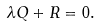<formula> <loc_0><loc_0><loc_500><loc_500>\lambda Q + R = 0 .</formula> 